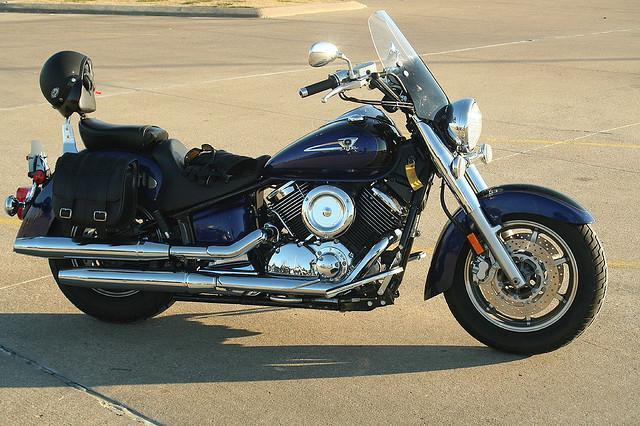How many vases glass vases are on the table?
Give a very brief answer. 0. 